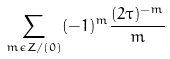<formula> <loc_0><loc_0><loc_500><loc_500>\sum _ { m \epsilon Z / ( 0 ) } ( - 1 ) ^ { m } \frac { ( 2 \tau ) ^ { - m } } { m }</formula> 